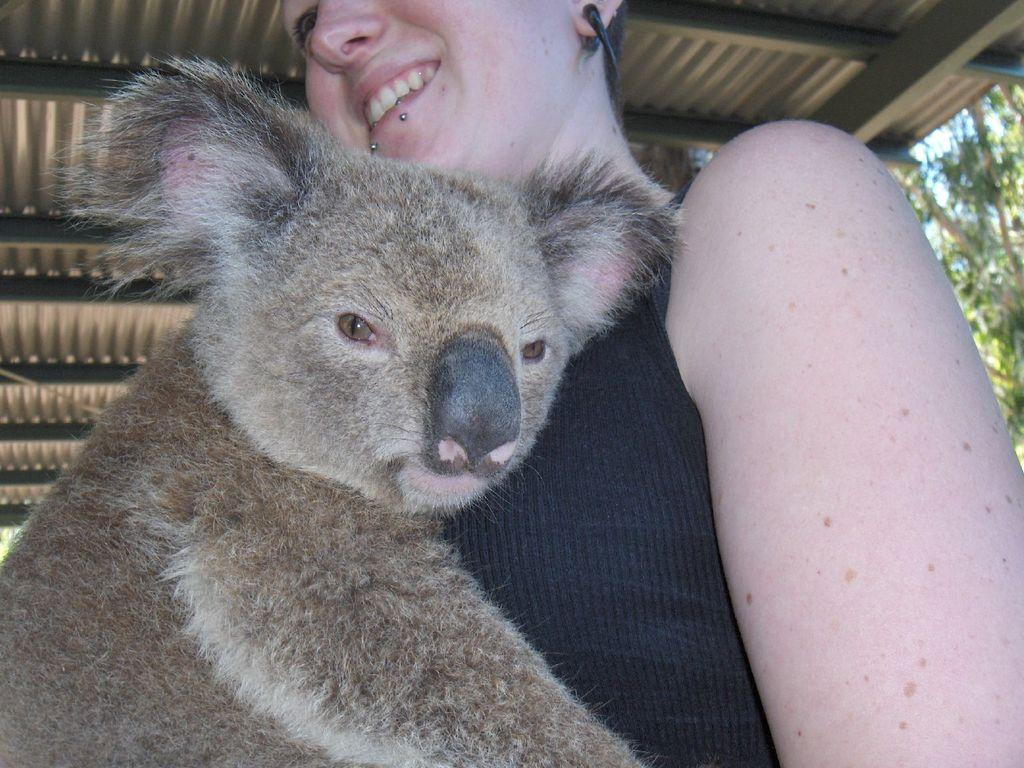What animal is in the foreground of the image? There is a koala in the foreground of the image. Who is with the koala in the foreground? There is a woman in the foreground of the image. Where is the woman positioned in relation to the koala? The woman is under a shed-like structure. What can be seen in the background of the image? There are trees in the background of the image. What is the chance of winning the lottery in the image? There is no mention of a lottery or any related information in the image, so it is impossible to determine the chance of winning. 